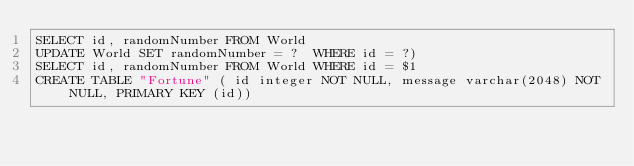Convert code to text. <code><loc_0><loc_0><loc_500><loc_500><_SQL_>SELECT id, randomNumber FROM World
UPDATE World SET randomNumber = ?  WHERE id = ?)
SELECT id, randomNumber FROM World WHERE id = $1
CREATE TABLE "Fortune" ( id integer NOT NULL, message varchar(2048) NOT NULL, PRIMARY KEY (id))</code> 